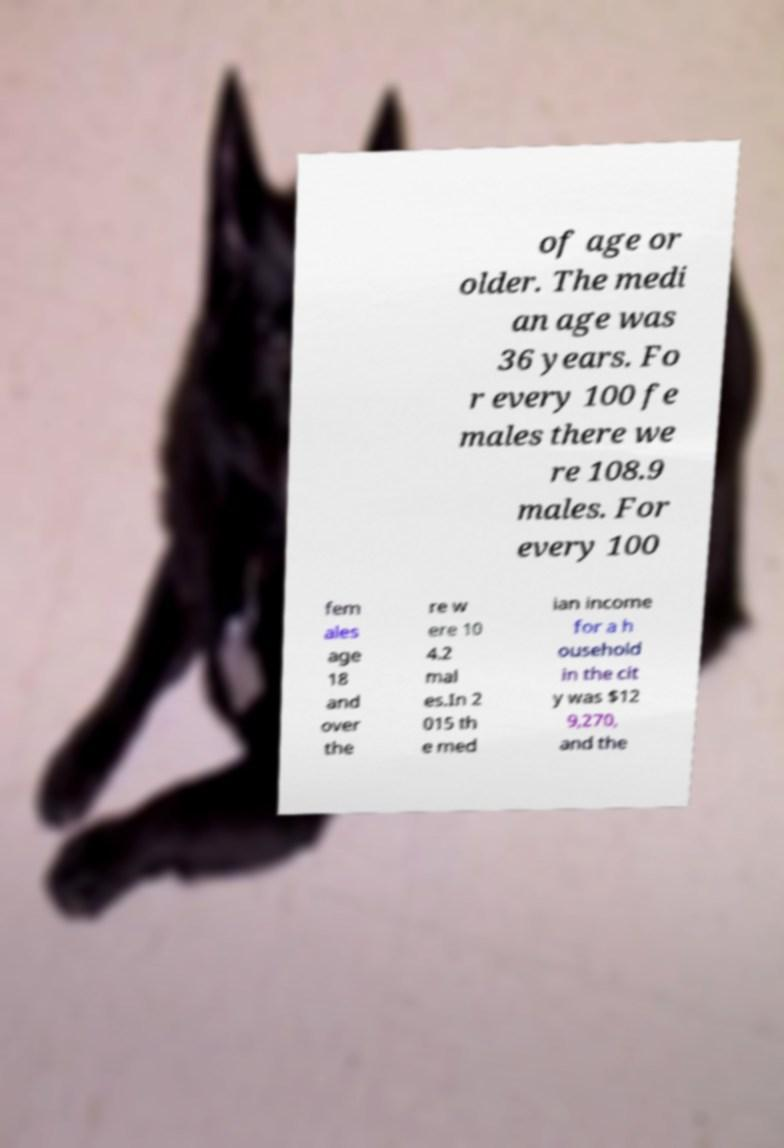Can you read and provide the text displayed in the image?This photo seems to have some interesting text. Can you extract and type it out for me? of age or older. The medi an age was 36 years. Fo r every 100 fe males there we re 108.9 males. For every 100 fem ales age 18 and over the re w ere 10 4.2 mal es.In 2 015 th e med ian income for a h ousehold in the cit y was $12 9,270, and the 